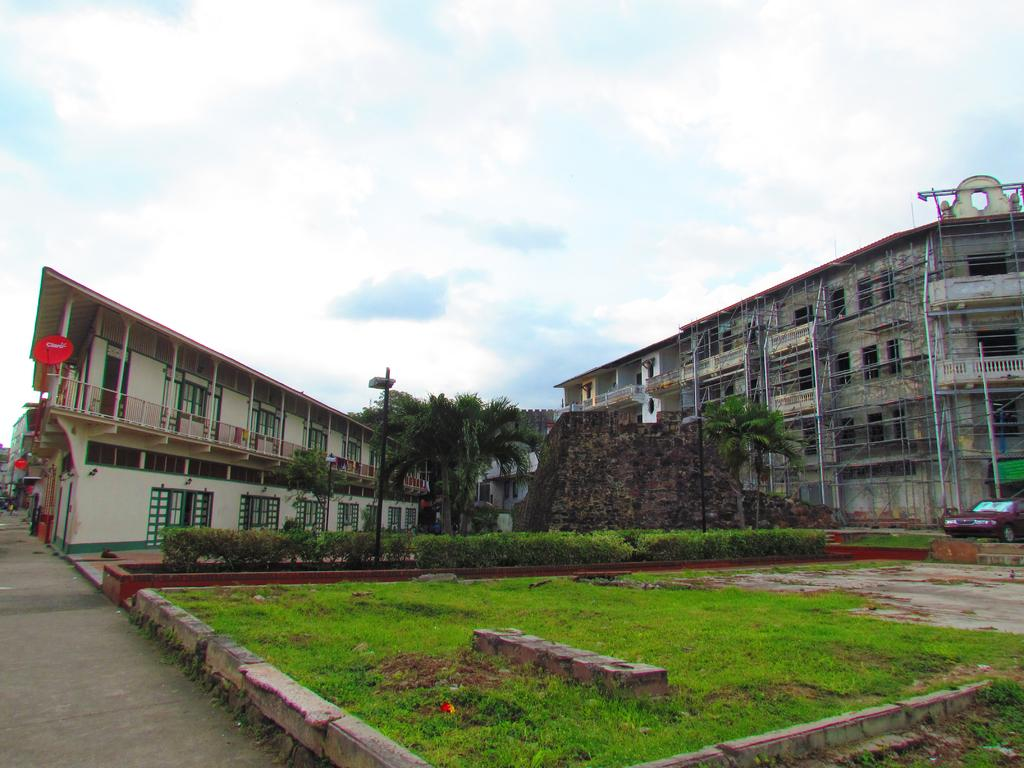What type of structures can be seen in the image? There are buildings in the image. What is the barrier made of in the image? There is a wall in the image. What type of vegetation is present in the image? There are trees and grass in the image. What is the source of light in the image? There is a light pole in the image. What is on the ground in the image? There is a vehicle on the ground in the image. What is visible at the top of the image? The sky is visible at the top of the image. Can you tell me how many times the vehicle sparked in the image? There is no indication of the vehicle sparking in the image; it is simply parked on the ground. What is the comparison between the buildings and the trees in the image? There is no comparison being made between the buildings and the trees in the image; they are simply two separate elements present in the scene. 